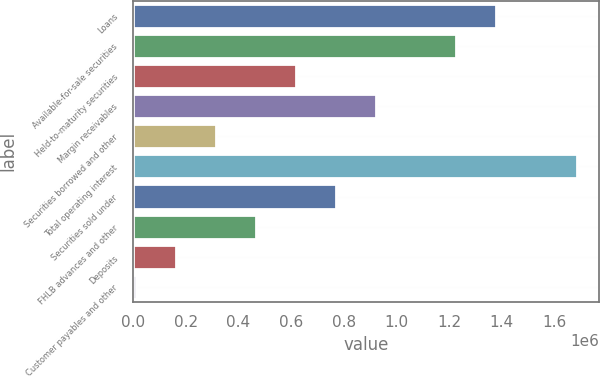<chart> <loc_0><loc_0><loc_500><loc_500><bar_chart><fcel>Loans<fcel>Available-for-sale securities<fcel>Held-to-maturity securities<fcel>Margin receivables<fcel>Securities borrowed and other<fcel>Total operating interest<fcel>Securities sold under<fcel>FHLB advances and other<fcel>Deposits<fcel>Customer payables and other<nl><fcel>1.38013e+06<fcel>1.22792e+06<fcel>619068<fcel>923492<fcel>314645<fcel>1.68455e+06<fcel>771280<fcel>466856<fcel>162433<fcel>10221<nl></chart> 